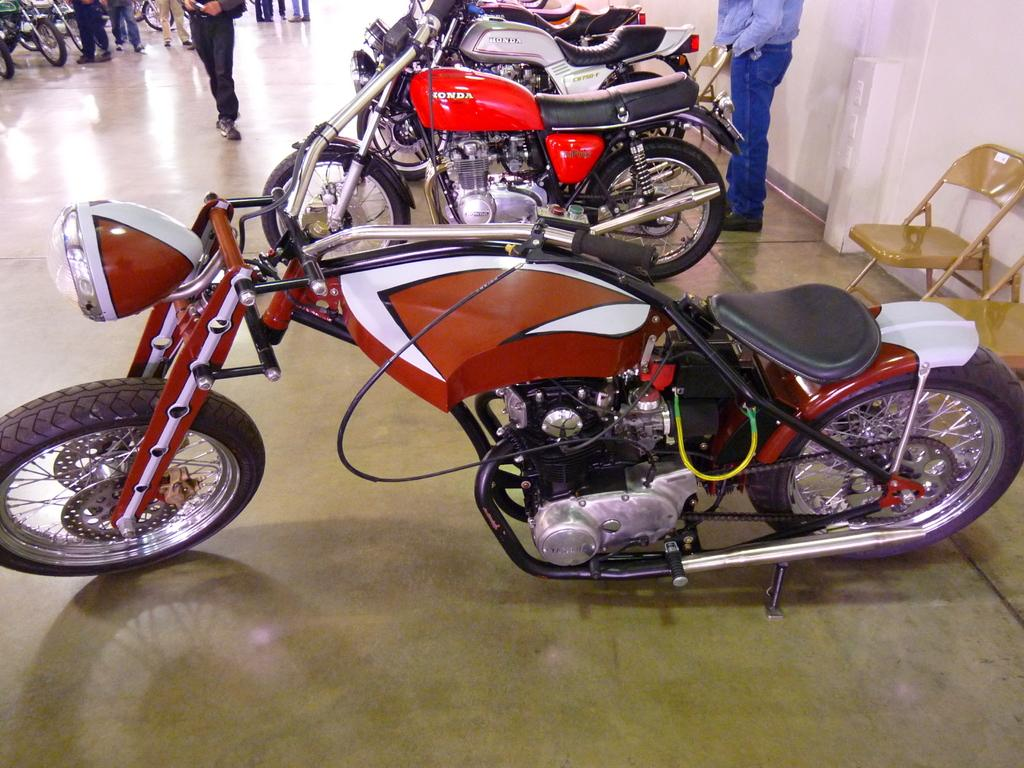What objects are on the floor in the image? There are motorbikes on the floor in the image. Who or what else is present in the image? There are people in the image. How many chairs are visible in the image? There are two empty chairs in the image. What can be seen on the wall in the image? There is a plain wall in the image. What type of print can be seen on the grain in the image? There is no print or grain present in the image. What is the downtown area like in the image? The image does not depict a downtown area; it features motorbikes, people, chairs, and a plain wall. 